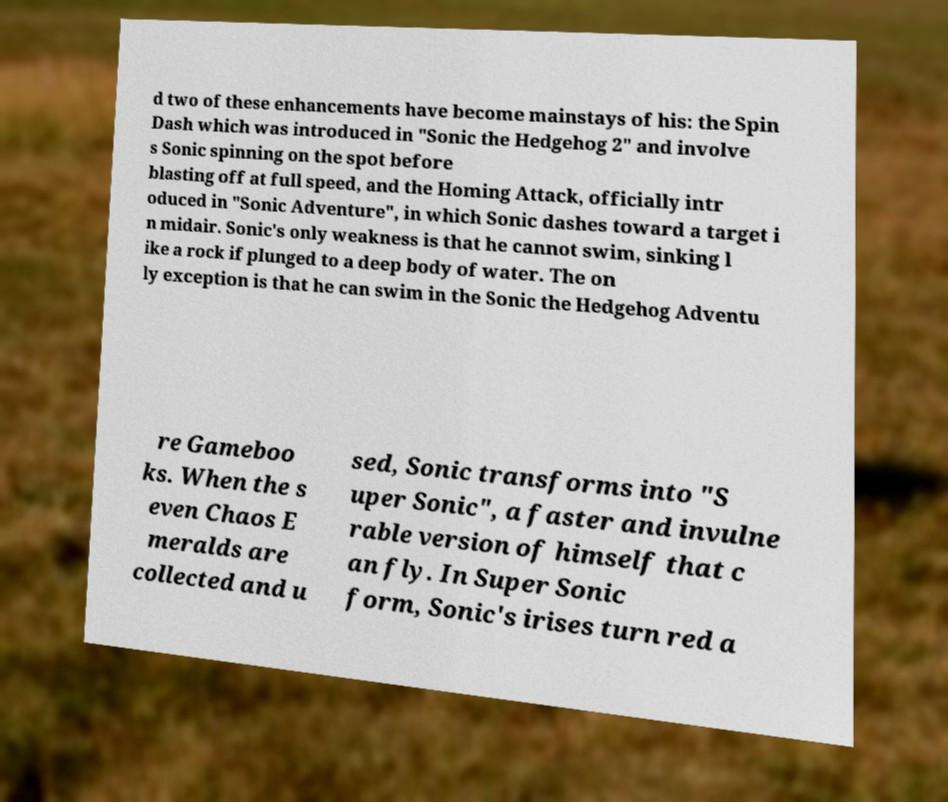Could you extract and type out the text from this image? d two of these enhancements have become mainstays of his: the Spin Dash which was introduced in "Sonic the Hedgehog 2" and involve s Sonic spinning on the spot before blasting off at full speed, and the Homing Attack, officially intr oduced in "Sonic Adventure", in which Sonic dashes toward a target i n midair. Sonic's only weakness is that he cannot swim, sinking l ike a rock if plunged to a deep body of water. The on ly exception is that he can swim in the Sonic the Hedgehog Adventu re Gameboo ks. When the s even Chaos E meralds are collected and u sed, Sonic transforms into "S uper Sonic", a faster and invulne rable version of himself that c an fly. In Super Sonic form, Sonic's irises turn red a 